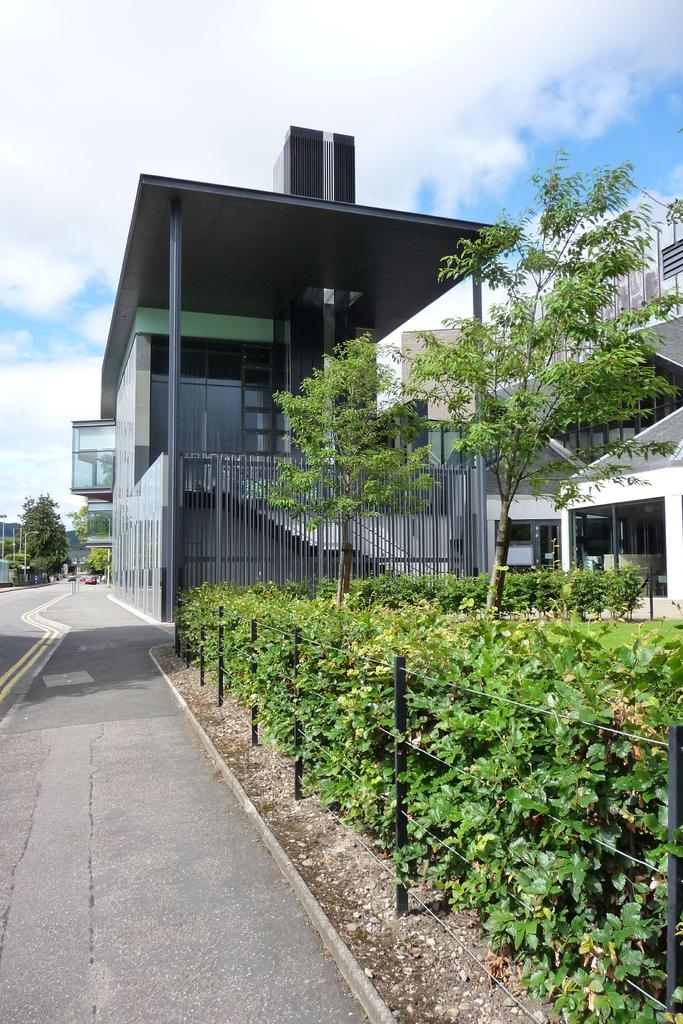What type of vegetation can be seen in the image? There are plants and trees in the image. What type of barrier is present in the image? There is a fence in the image. What type of structures are visible in the image? There are buildings in the image. What type of pathway is present in the image? There is a road in the image. What can be seen in the background of the image? The sky is visible in the background of the image. Can you see the family enjoying the beach in the image? There is no beach or family present in the image. What type of country is depicted in the image? The image does not depict a specific country; it shows plants, trees, a fence, buildings, a road, and the sky. 